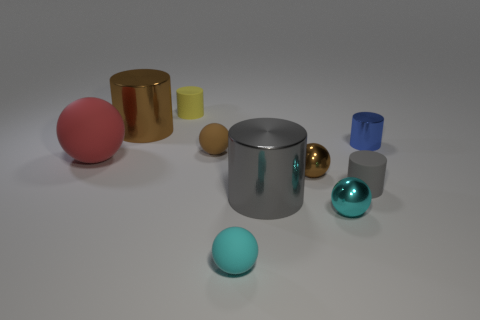How many things are yellow rubber cylinders or small cylinders that are in front of the brown metal cylinder?
Give a very brief answer. 3. What material is the red object?
Offer a terse response. Rubber. There is another small gray object that is the same shape as the gray metallic object; what is it made of?
Offer a terse response. Rubber. The tiny thing that is on the right side of the tiny cylinder that is in front of the blue metallic object is what color?
Your response must be concise. Blue. How many rubber things are big red balls or gray cylinders?
Your response must be concise. 2. Does the tiny yellow thing have the same material as the red sphere?
Your answer should be very brief. Yes. What is the cylinder to the right of the rubber cylinder that is in front of the tiny blue cylinder made of?
Your answer should be compact. Metal. What number of big things are red rubber cylinders or cyan shiny balls?
Your response must be concise. 0. What is the size of the brown metal sphere?
Your answer should be very brief. Small. Are there more big red matte spheres that are behind the tiny yellow matte thing than tiny purple cylinders?
Provide a short and direct response. No. 